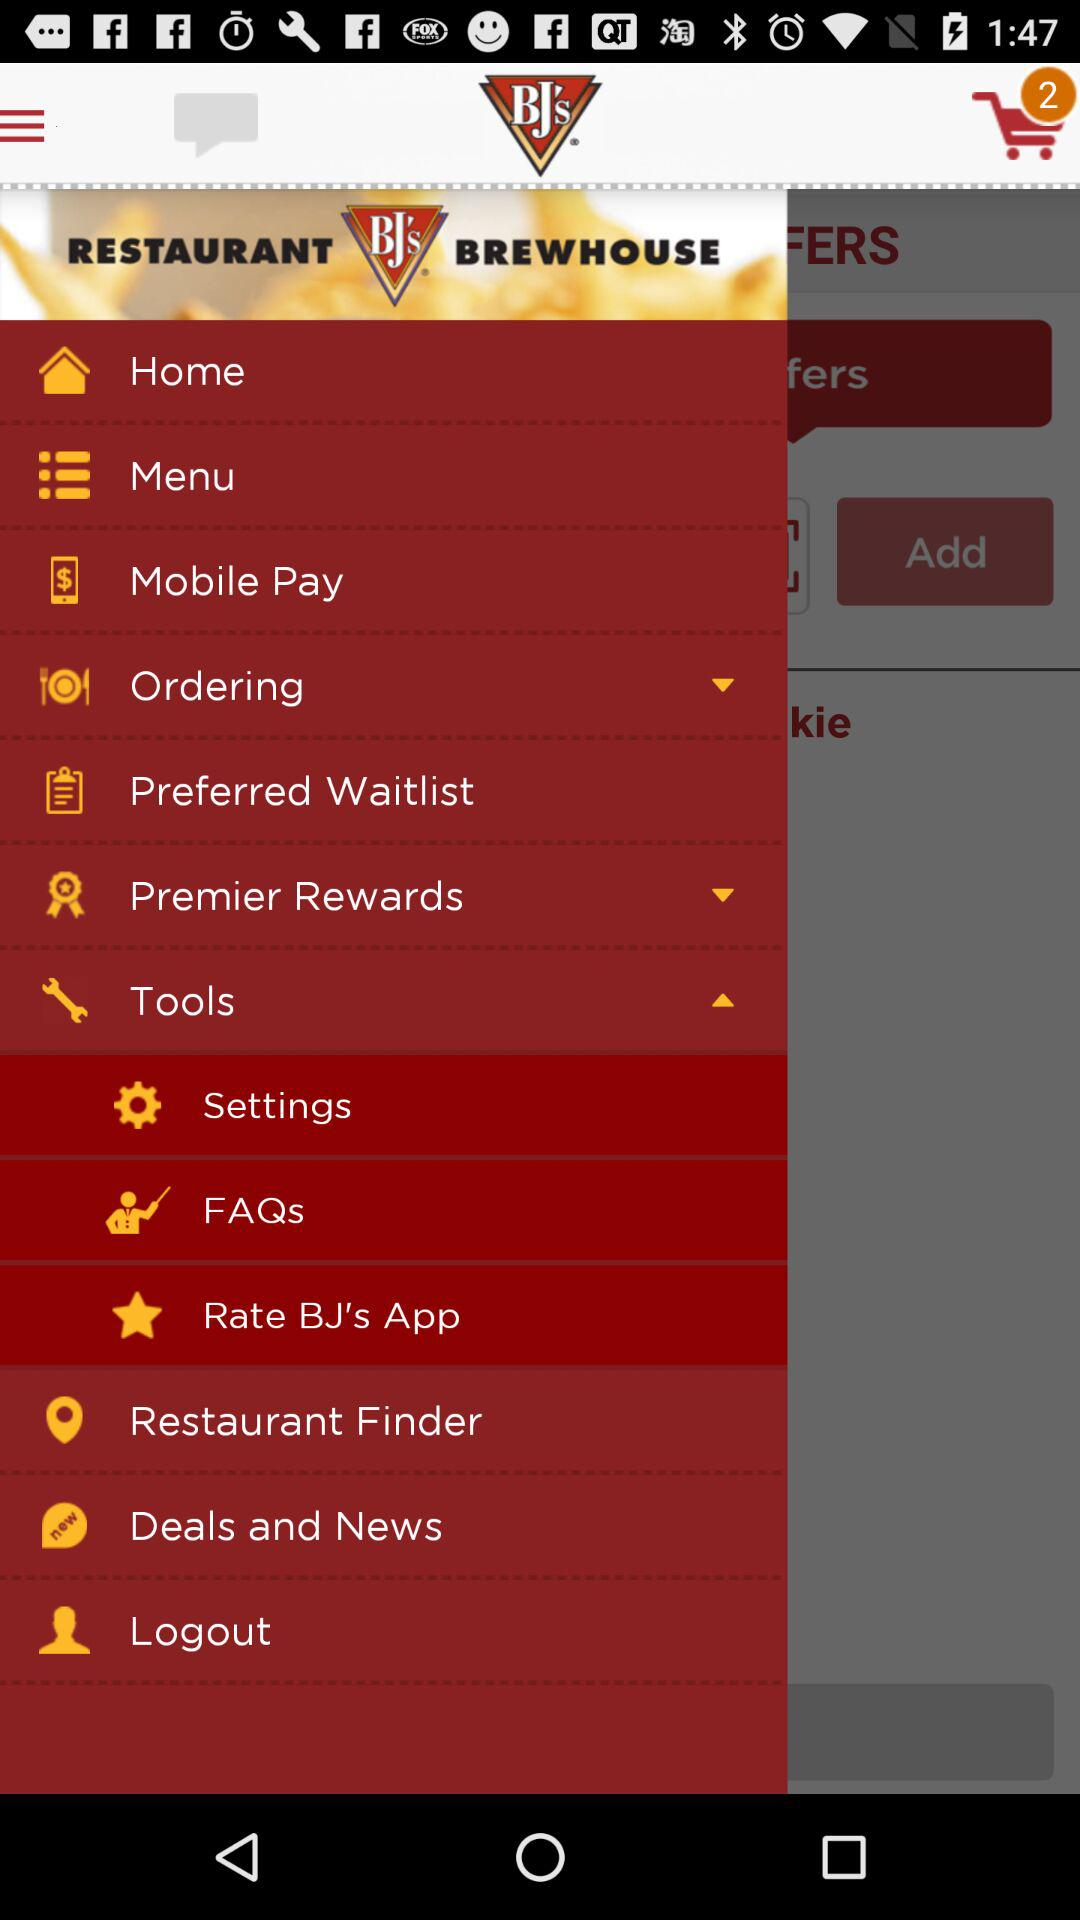What is the name of the application? The name of the application is "BJ's RESTAURANT BREWHOUSE". 